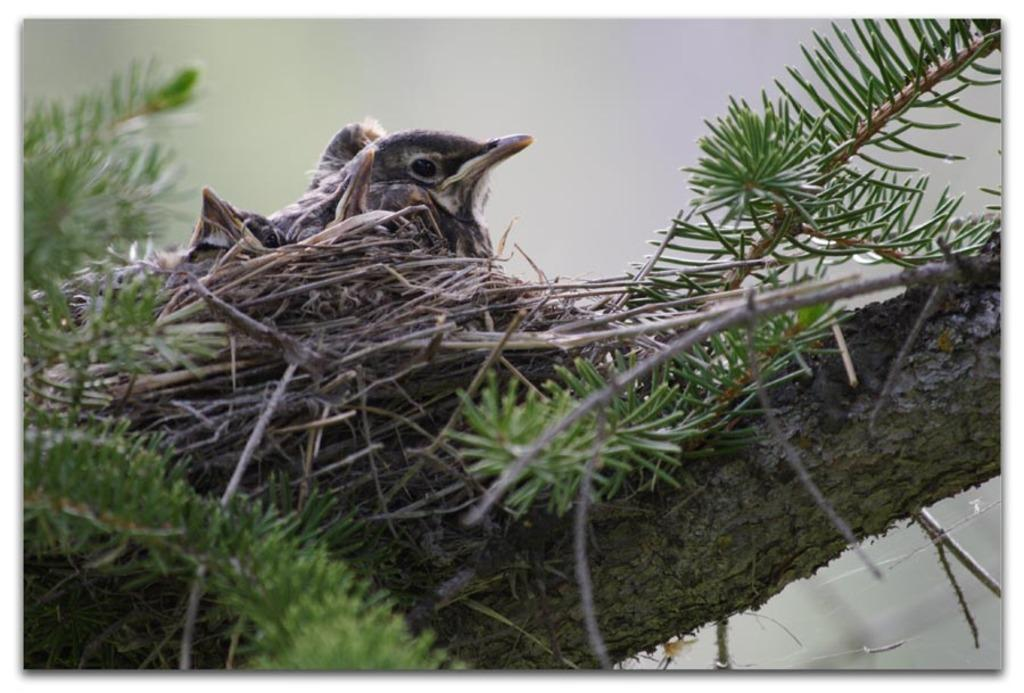What is located on the tree in the image? There is a nest on the tree in the image. What can be found inside the nest? There is a bird in the nest. Can you describe the bird's habitat in the image? The bird's habitat is a nest on a tree. What type of eggnog is being served in the image? There is no eggnog present in the image; it features a nest with a bird on a tree. What level of rice production can be observed in the image? There is no rice production or reference to rice in the image. 